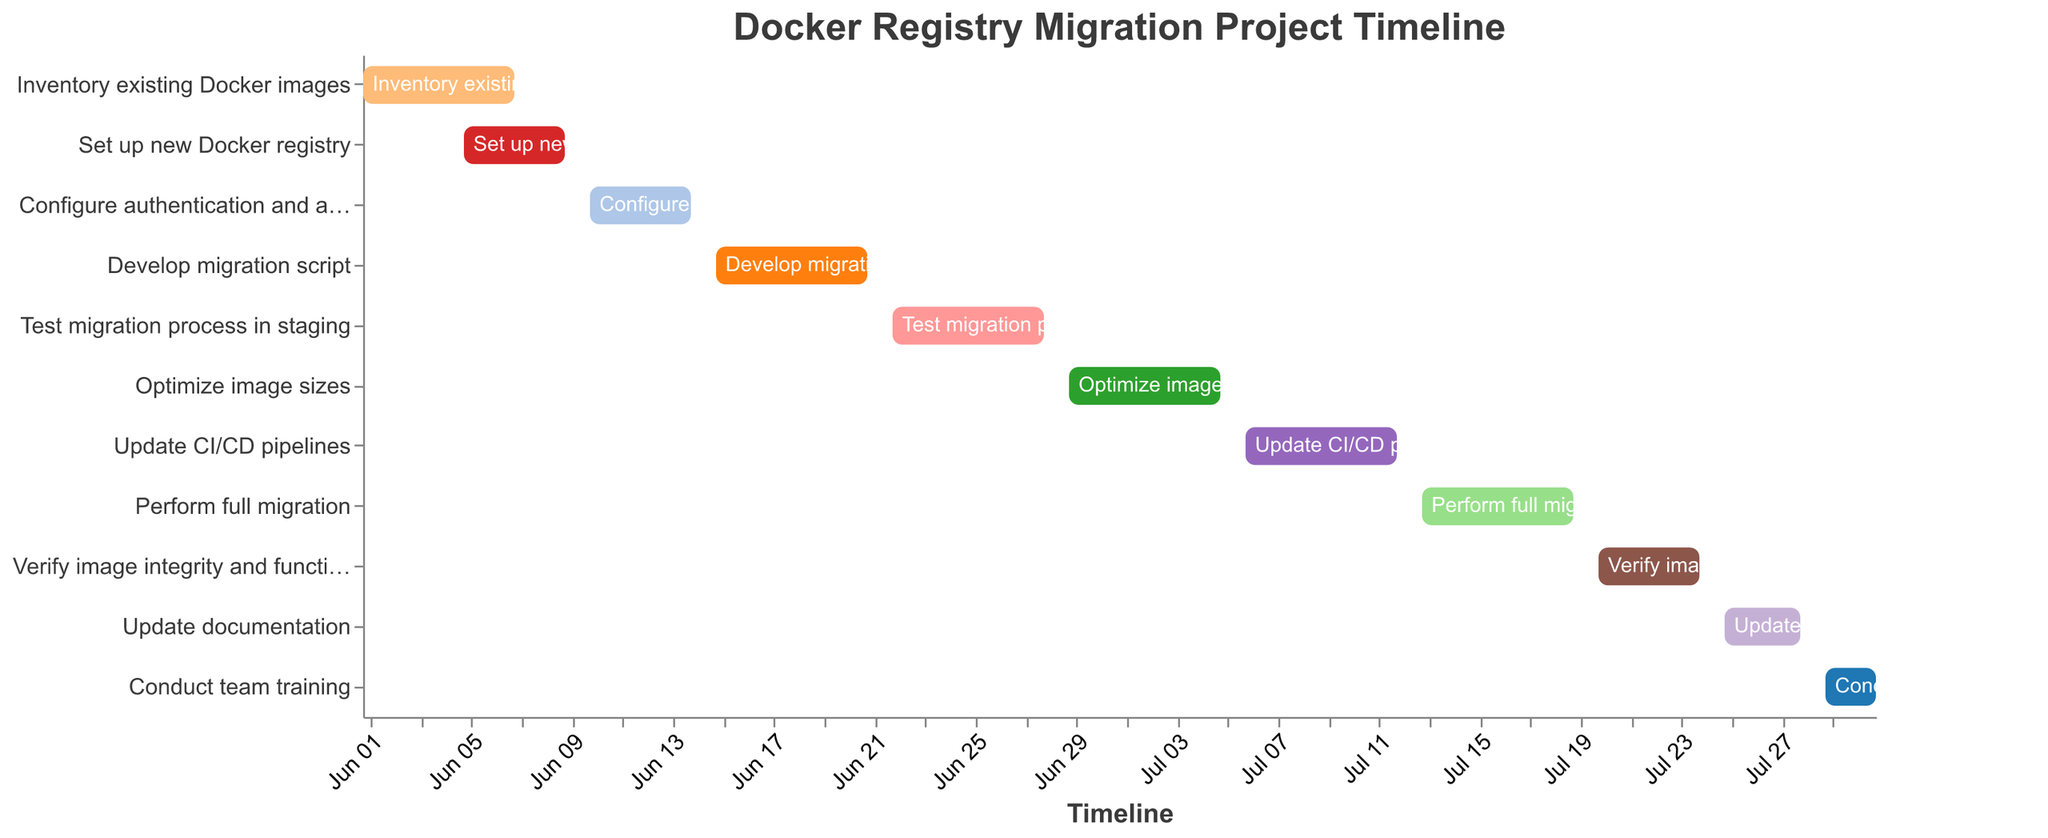What's the title of the Gantt Chart? The title of the Gantt Chart is written at the top of the chart.
Answer: Docker Registry Migration Project Timeline Which task has the shortest duration? The task with the shortest duration can be identified by finding the task with the shortest bar.
Answer: Conduct team training Which tasks overlap with "Set up new Docker registry"? To find overlapping tasks, check which tasks have their date range intersecting with "Set up new Docker registry" (June 5 to June 9). "Inventory existing Docker images" overlaps from June 5 to June 7.
Answer: Inventory existing Docker images What is the total number of tasks in the project? Count the number of different tasks listed on the y-axis of the chart.
Answer: 11 Which tasks directly follow "Develop migration script"? The task following "Develop migration script" starts immediately after its end date, which is June 21. The next task starting right after is "Test migration process in staging" starting on June 22.
Answer: Test migration process in staging How long is the entire project duration? The entire project duration is calculated by finding the difference between the start date of the first task and the end date of the last task (June 1 to July 31).
Answer: 61 days Which task ends on July 12? To find the task ending on July 12, refer to the end dates of the tasks.
Answer: Update CI/CD pipelines When does "Verify image integrity and functionality" start and end? The start and end dates for "Verify image integrity and functionality" can be read directly from the chart.
Answer: July 20 to July 24 Which task has the same duration as "Configure authentication and access control"? "Configure authentication and access control" has a duration of 5 days. Find another task with the same duration in the figure.
Answer: Verify image integrity and functionality 